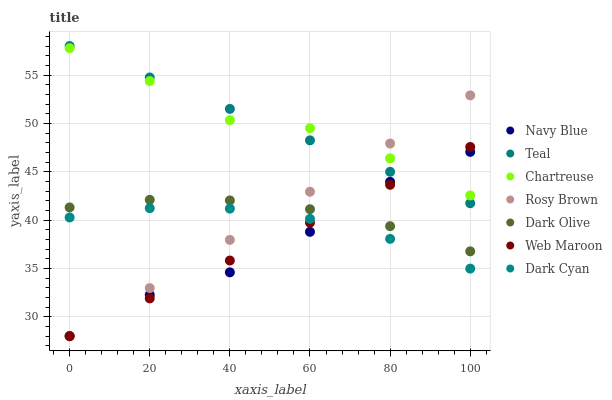Does Navy Blue have the minimum area under the curve?
Answer yes or no. Yes. Does Chartreuse have the maximum area under the curve?
Answer yes or no. Yes. Does Dark Olive have the minimum area under the curve?
Answer yes or no. No. Does Dark Olive have the maximum area under the curve?
Answer yes or no. No. Is Web Maroon the smoothest?
Answer yes or no. Yes. Is Navy Blue the roughest?
Answer yes or no. Yes. Is Dark Olive the smoothest?
Answer yes or no. No. Is Dark Olive the roughest?
Answer yes or no. No. Does Rosy Brown have the lowest value?
Answer yes or no. Yes. Does Navy Blue have the lowest value?
Answer yes or no. No. Does Teal have the highest value?
Answer yes or no. Yes. Does Navy Blue have the highest value?
Answer yes or no. No. Is Dark Olive less than Teal?
Answer yes or no. Yes. Is Teal greater than Dark Cyan?
Answer yes or no. Yes. Does Rosy Brown intersect Navy Blue?
Answer yes or no. Yes. Is Rosy Brown less than Navy Blue?
Answer yes or no. No. Is Rosy Brown greater than Navy Blue?
Answer yes or no. No. Does Dark Olive intersect Teal?
Answer yes or no. No. 